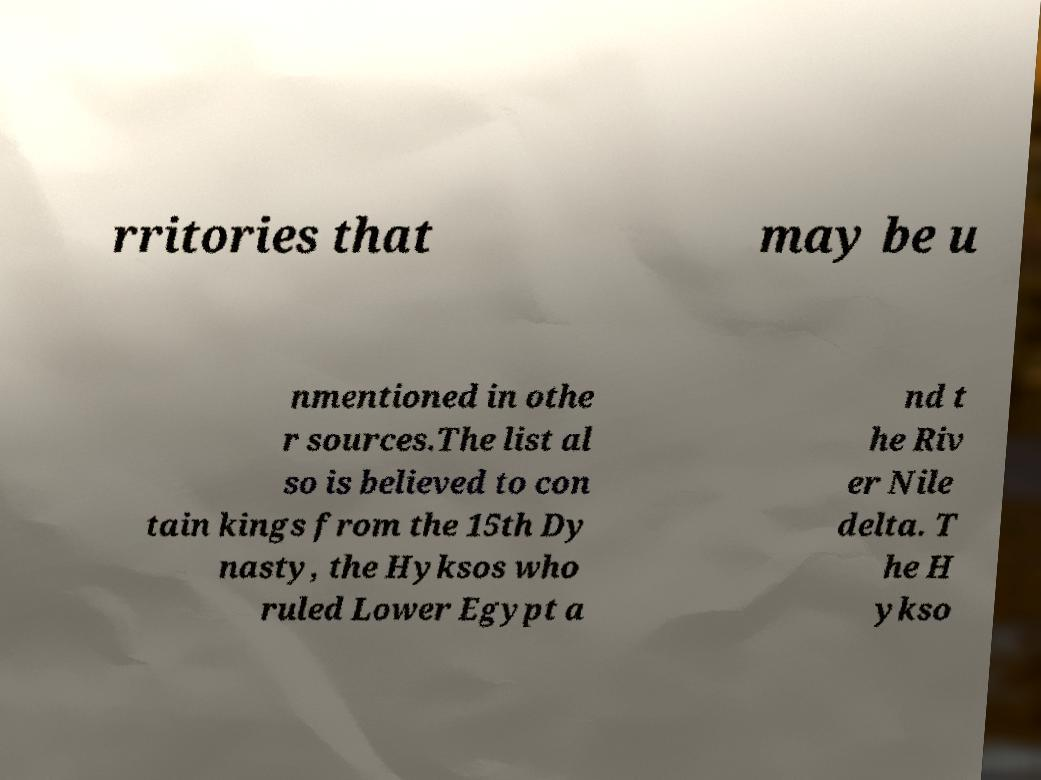Can you read and provide the text displayed in the image?This photo seems to have some interesting text. Can you extract and type it out for me? rritories that may be u nmentioned in othe r sources.The list al so is believed to con tain kings from the 15th Dy nasty, the Hyksos who ruled Lower Egypt a nd t he Riv er Nile delta. T he H ykso 